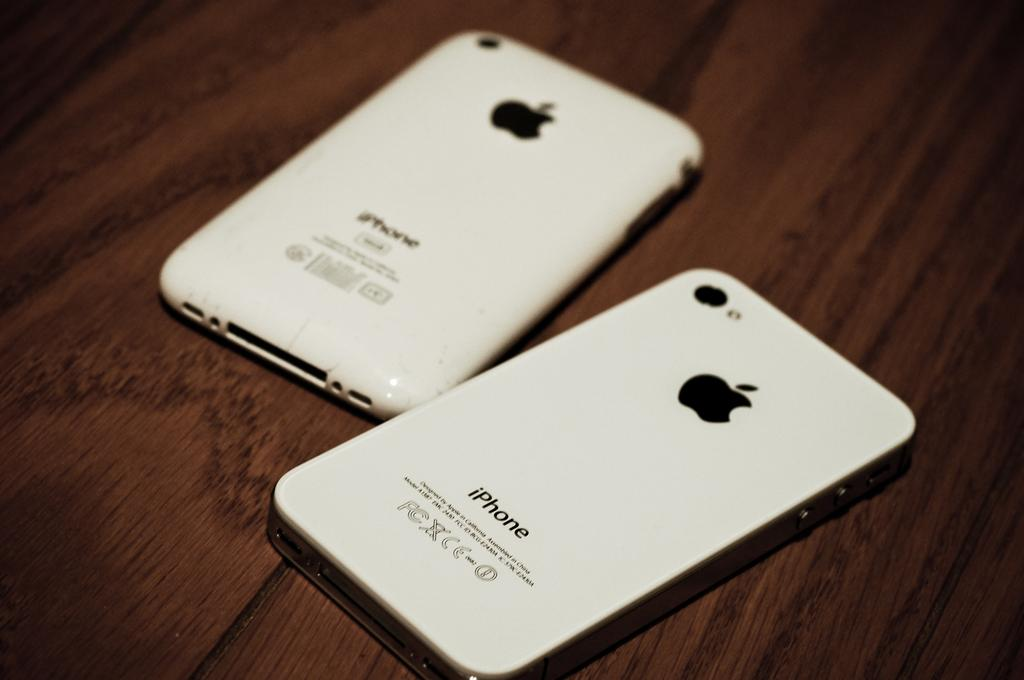<image>
Present a compact description of the photo's key features. A couple of Apple iPhones on top of a table. 